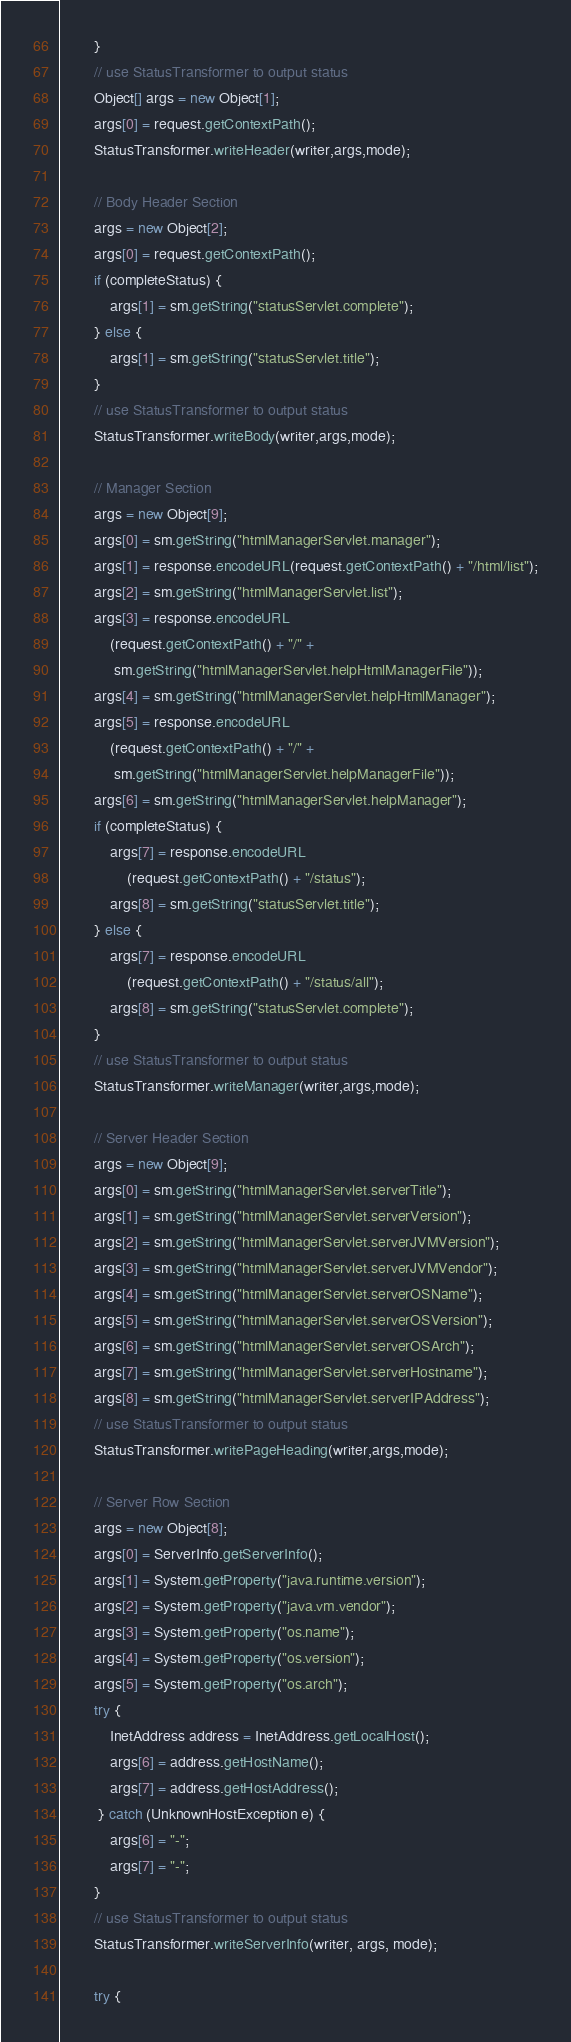<code> <loc_0><loc_0><loc_500><loc_500><_Java_>        }
        // use StatusTransformer to output status
        Object[] args = new Object[1];
        args[0] = request.getContextPath();
        StatusTransformer.writeHeader(writer,args,mode);

        // Body Header Section
        args = new Object[2];
        args[0] = request.getContextPath();
        if (completeStatus) {
            args[1] = sm.getString("statusServlet.complete");
        } else {
            args[1] = sm.getString("statusServlet.title");
        }
        // use StatusTransformer to output status
        StatusTransformer.writeBody(writer,args,mode);

        // Manager Section
        args = new Object[9];
        args[0] = sm.getString("htmlManagerServlet.manager");
        args[1] = response.encodeURL(request.getContextPath() + "/html/list");
        args[2] = sm.getString("htmlManagerServlet.list");
        args[3] = response.encodeURL
            (request.getContextPath() + "/" +
             sm.getString("htmlManagerServlet.helpHtmlManagerFile"));
        args[4] = sm.getString("htmlManagerServlet.helpHtmlManager");
        args[5] = response.encodeURL
            (request.getContextPath() + "/" +
             sm.getString("htmlManagerServlet.helpManagerFile"));
        args[6] = sm.getString("htmlManagerServlet.helpManager");
        if (completeStatus) {
            args[7] = response.encodeURL
                (request.getContextPath() + "/status");
            args[8] = sm.getString("statusServlet.title");
        } else {
            args[7] = response.encodeURL
                (request.getContextPath() + "/status/all");
            args[8] = sm.getString("statusServlet.complete");
        }
        // use StatusTransformer to output status
        StatusTransformer.writeManager(writer,args,mode);

        // Server Header Section
        args = new Object[9];
        args[0] = sm.getString("htmlManagerServlet.serverTitle");
        args[1] = sm.getString("htmlManagerServlet.serverVersion");
        args[2] = sm.getString("htmlManagerServlet.serverJVMVersion");
        args[3] = sm.getString("htmlManagerServlet.serverJVMVendor");
        args[4] = sm.getString("htmlManagerServlet.serverOSName");
        args[5] = sm.getString("htmlManagerServlet.serverOSVersion");
        args[6] = sm.getString("htmlManagerServlet.serverOSArch");
        args[7] = sm.getString("htmlManagerServlet.serverHostname");
        args[8] = sm.getString("htmlManagerServlet.serverIPAddress");
        // use StatusTransformer to output status
        StatusTransformer.writePageHeading(writer,args,mode);

        // Server Row Section
        args = new Object[8];
        args[0] = ServerInfo.getServerInfo();
        args[1] = System.getProperty("java.runtime.version");
        args[2] = System.getProperty("java.vm.vendor");
        args[3] = System.getProperty("os.name");
        args[4] = System.getProperty("os.version");
        args[5] = System.getProperty("os.arch");
        try {
            InetAddress address = InetAddress.getLocalHost();
            args[6] = address.getHostName();
            args[7] = address.getHostAddress();
         } catch (UnknownHostException e) {
            args[6] = "-";
            args[7] = "-";
        }
        // use StatusTransformer to output status
        StatusTransformer.writeServerInfo(writer, args, mode);

        try {
</code> 